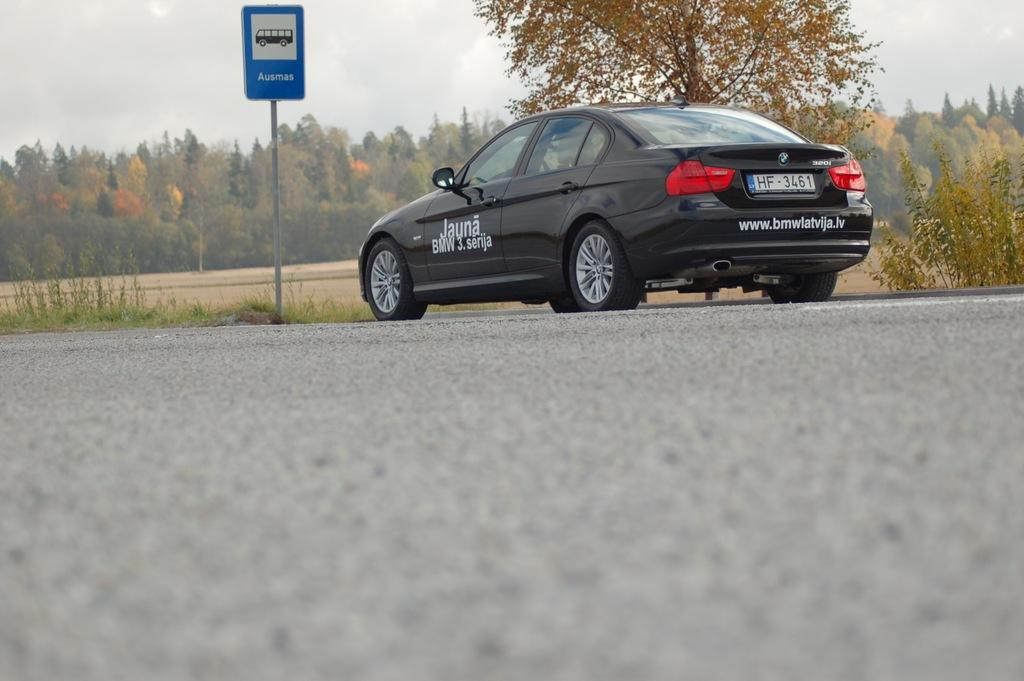What is the main subject of the image? There is a car in the image. What can be seen in the background of the image? There is a sign board with a pole and trees visible in the background. What else is visible in the background? The sky is also visible in the background. Are there any plants in the image? Yes, there are plants in the image. What type of destruction can be seen happening to the car in the image? There is no destruction happening to the car in the image; it appears to be parked or stationary. Can you see a sack or lock on the car in the image? No, there is no sack or lock visible on the car in the image. 